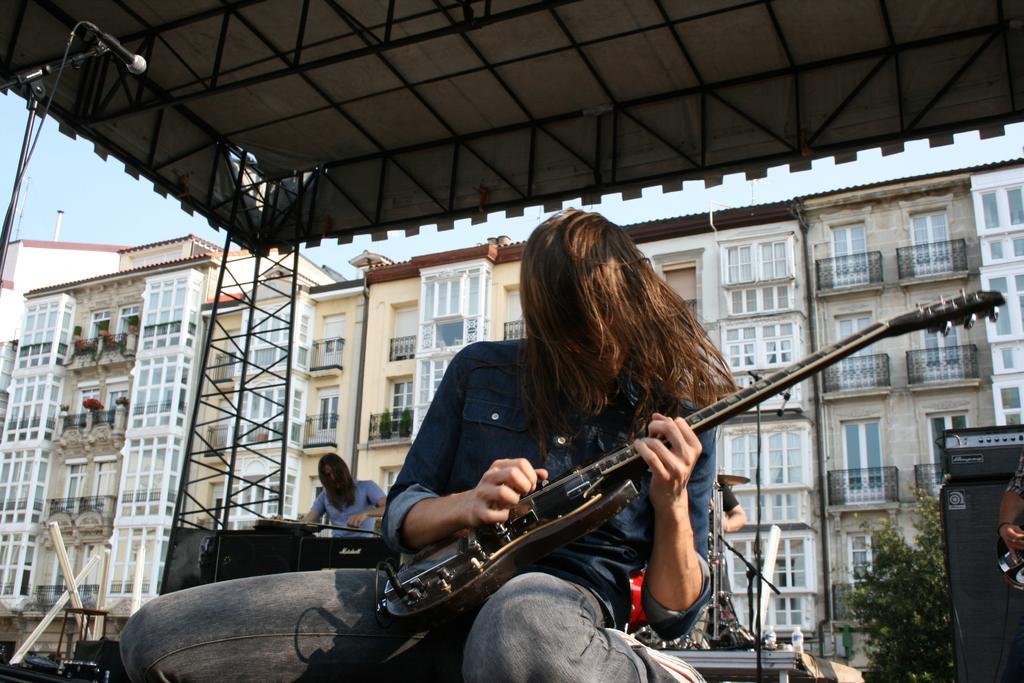In one or two sentences, can you explain what this image depicts? In this image i can see a person sitting and holding a guitar in his hands. In the background i can see a building, the sky and another person standing. 